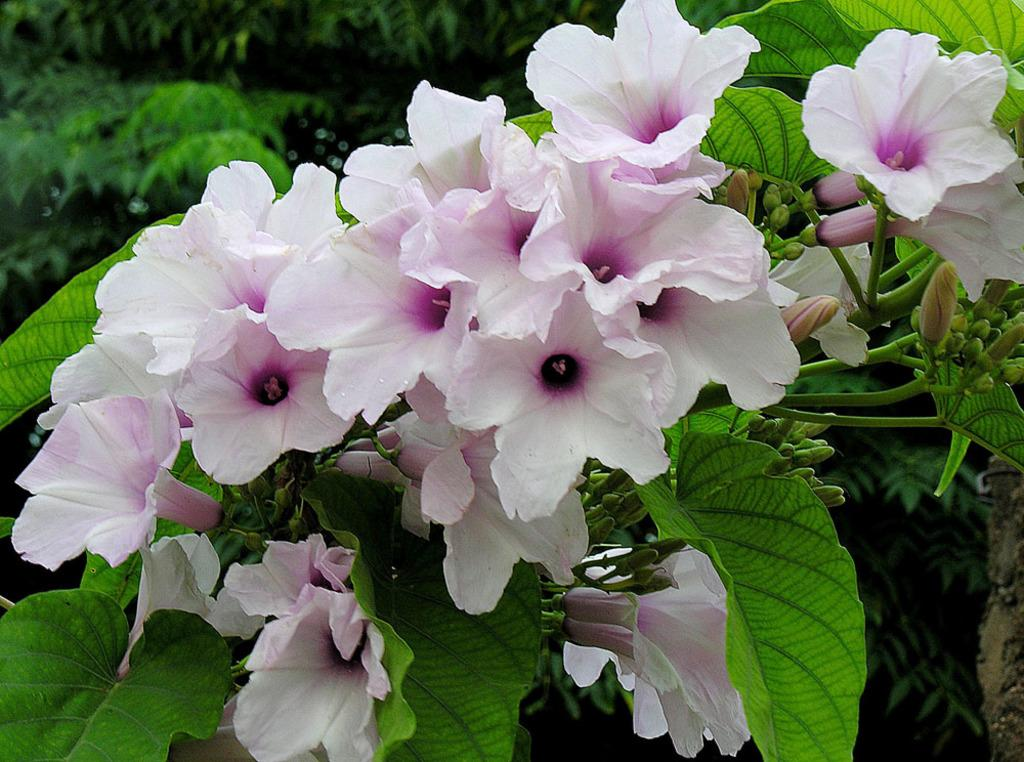What type of plant life can be seen in the image? There are flowers, leaves, stems, and flower buds in the image. Are there any plants visible in the background of the image? Yes, there are plants in the background of the image. What type of throne can be seen in the image? There is no throne present in the image; it features plant life. What does the image smell like? The image does not have a smell, as it is a visual representation. 